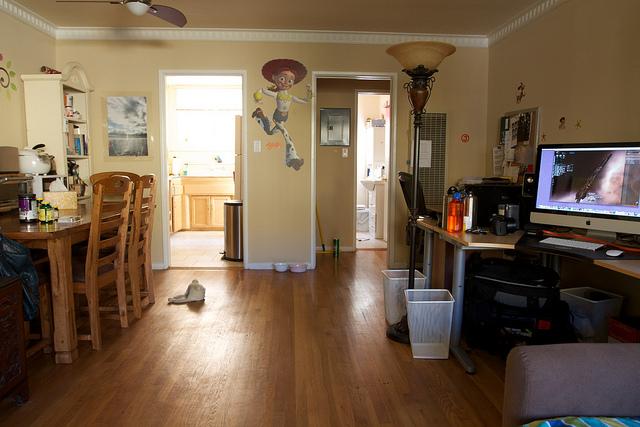Is there a Toy Story character on the wall?
Give a very brief answer. Yes. Is the computer monitor on?
Answer briefly. Yes. Is the table sturdy?
Short answer required. Yes. Where is this room?
Keep it brief. House. 